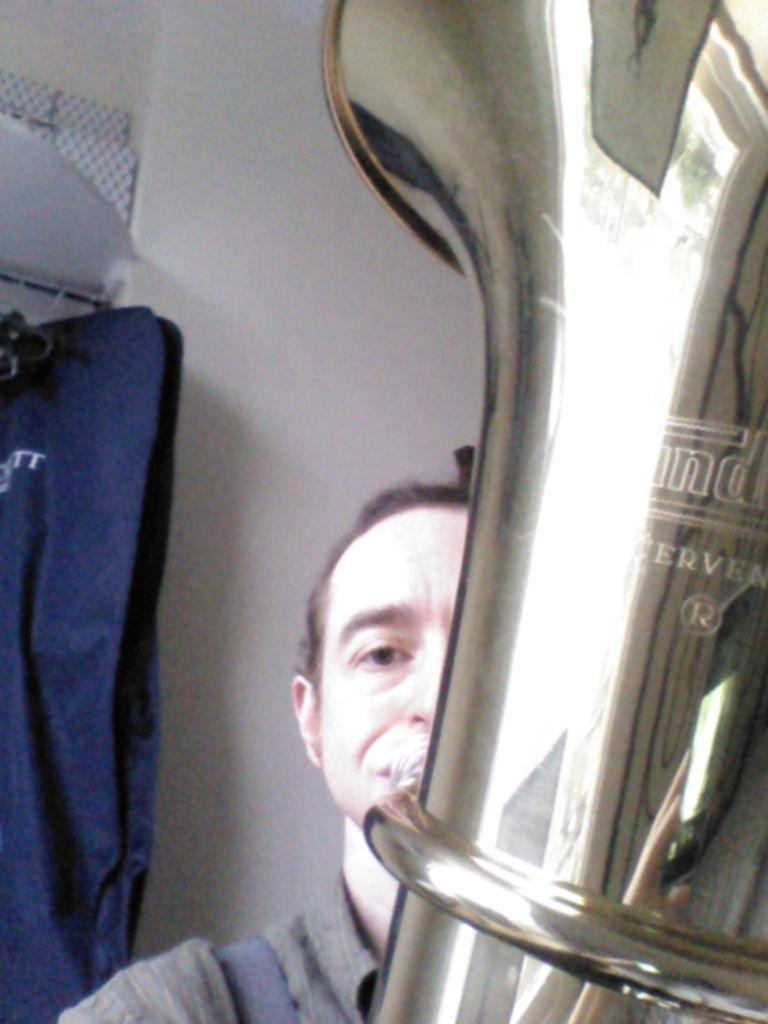What is the man in the image doing? The man is playing a musical instrument in the image. Can you describe the blue object hanging from a rod on the left side of the image? There is a blue object hanging from a rod on the left side of the image. What is the color of the wall in the image? There is a white wall in the image. How many songs can be heard coming from the man's neck in the image? There is no indication in the image that the man has songs coming from his neck, as the image only shows him playing a musical instrument. 